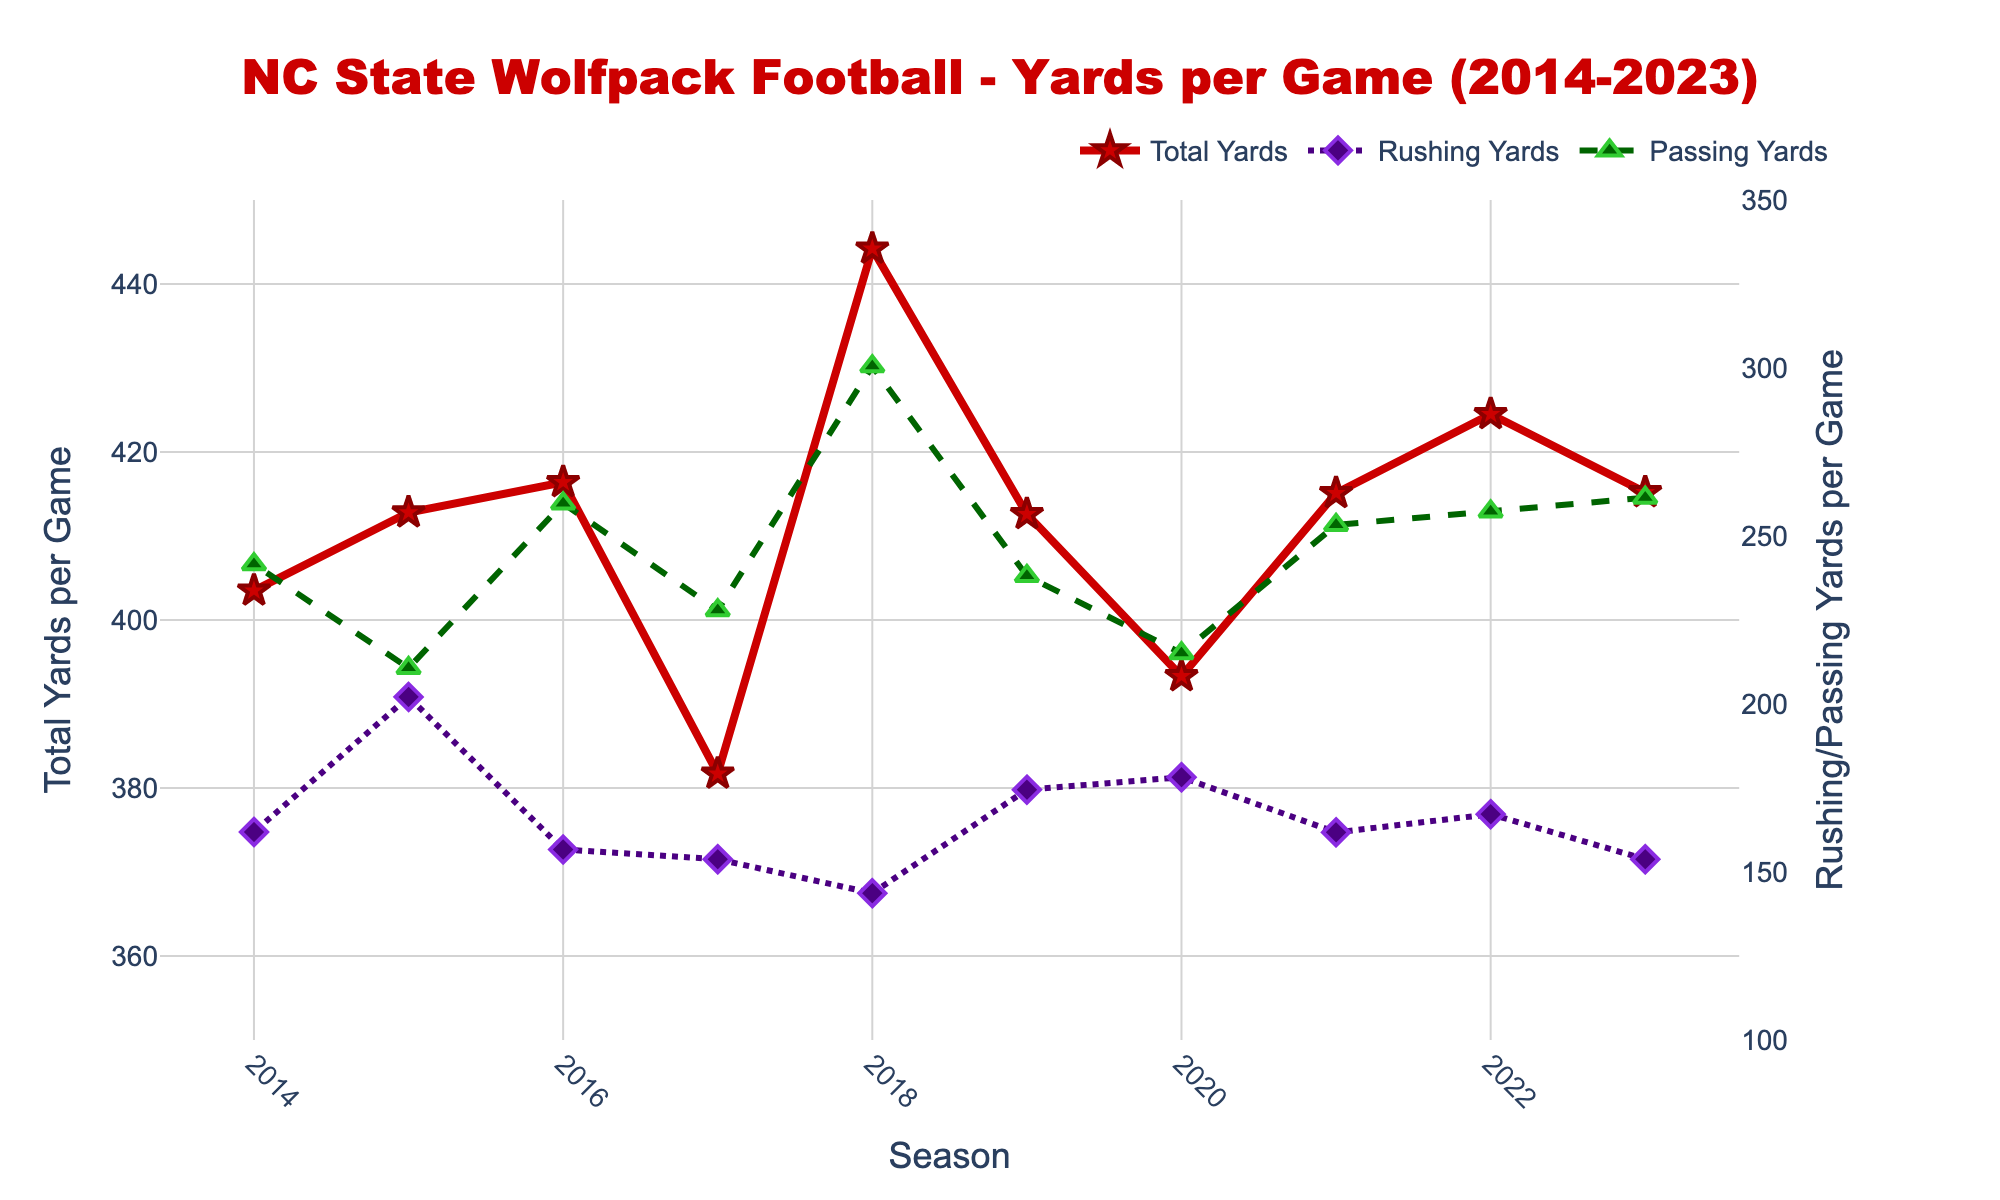Which season had the highest total yards per game? The line representing total yards per game is shown in red. By inspecting the highest peak on this line, it can be seen that 2018 had the highest value.
Answer: 2018 Which season had the lowest total yards per game? The line representing total yards per game shows its lowest point for the season indicated. Upon inspection, 2017 had the lowest total yards per game.
Answer: 2017 By how much did passing yards per game increase from 2017 to 2018? The green dashed line represents passing yards per game. In 2017, passing yards per game were approximately 227.9, and in 2018, they were approximately 300.5. Subtracting these gives an increase of 72.6.
Answer: 72.6 Compare the rushing and passing yards per game for the 2020 season. Which was higher and by how much? For the 2020 season, the purple dotted line (rushing yards) is at 178.2, and the green dashed line (passing yards) is at 215.1. Subtract the rushing from the passing to find the difference, which is 36.9.
Answer: Passing by 36.9 What is the difference in total yards per game between the highest and lowest seasons? The highest total yards per game was 444.2 in 2018, and the lowest was 381.7 in 2017. Subtract the lowest from the highest to find the difference, which is 62.5.
Answer: 62.5 What was the trend in rushing yards per game from 2015 to 2017? Observing the purple dotted line for the years between 2015 and 2017, rushing yards per game consistently decreased from 202.1 in 2015 to 161.9 in 2016, and further down to 153.8 in 2017.
Answer: Decreasing In which season did the rushing yards per game and passing yards per game lines intersect? The intersection point occurs where the purple and green lines cross. Observing the plot, this happens in the 2015 season at around the 202.1 rushing and 210.7 passing yards per game point.
Answer: 2015 What was the approximate average total yards per game from 2020 to 2023? The total yards per game for 2020 (393.3), 2021 (415.1), 2022 (424.5), and 2023 (415.2) need to be summed up, then divided by 4. (393.3 + 415.1 + 424.5 + 415.2) / 4 = 412.0.
Answer: 412.0 Compare the total yards per game for 2018 and 2019. How much did it decrease? In 2018, the total yards per game were 444.2, and in 2019, it was 412.6. Subtracting the latter from the former gives 31.6.
Answer: 31.6 How did the passing yards per game change from 2019 to 2020? The green dashed line for passing yards per game shows a value of 238.1 in 2019 and 215.1 in 2020. Subtracting the 2020 value from the 2019 value gives a decrease of 23.0.
Answer: Decreased by 23.0 